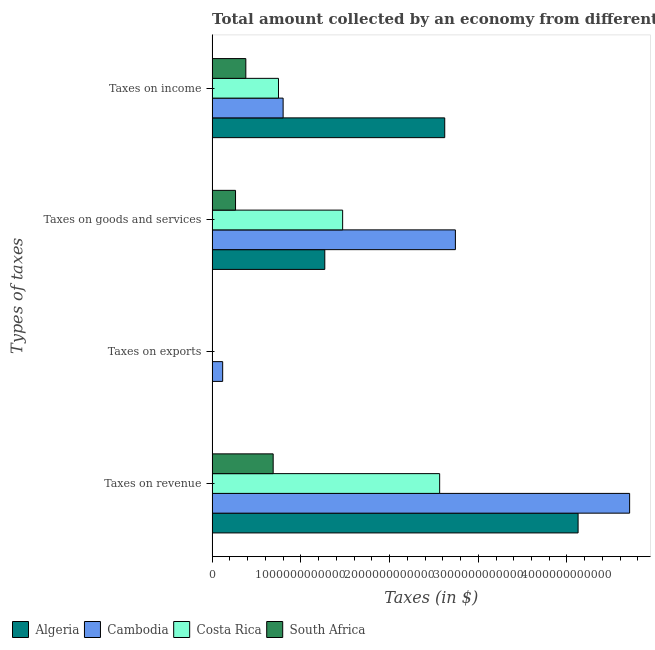How many bars are there on the 3rd tick from the bottom?
Your response must be concise. 4. What is the label of the 3rd group of bars from the top?
Make the answer very short. Taxes on exports. What is the amount collected as tax on income in South Africa?
Ensure brevity in your answer.  3.80e+11. Across all countries, what is the maximum amount collected as tax on income?
Offer a very short reply. 2.62e+12. Across all countries, what is the minimum amount collected as tax on income?
Make the answer very short. 3.80e+11. In which country was the amount collected as tax on exports maximum?
Provide a short and direct response. Cambodia. In which country was the amount collected as tax on income minimum?
Give a very brief answer. South Africa. What is the total amount collected as tax on revenue in the graph?
Give a very brief answer. 1.21e+13. What is the difference between the amount collected as tax on revenue in Cambodia and that in Costa Rica?
Keep it short and to the point. 2.14e+12. What is the difference between the amount collected as tax on income in Algeria and the amount collected as tax on exports in Cambodia?
Offer a very short reply. 2.50e+12. What is the average amount collected as tax on income per country?
Provide a succinct answer. 1.14e+12. What is the difference between the amount collected as tax on revenue and amount collected as tax on goods in Costa Rica?
Your answer should be compact. 1.09e+12. What is the ratio of the amount collected as tax on goods in Algeria to that in Cambodia?
Provide a succinct answer. 0.46. Is the amount collected as tax on goods in Costa Rica less than that in Cambodia?
Keep it short and to the point. Yes. Is the difference between the amount collected as tax on goods in South Africa and Algeria greater than the difference between the amount collected as tax on exports in South Africa and Algeria?
Ensure brevity in your answer.  No. What is the difference between the highest and the second highest amount collected as tax on exports?
Give a very brief answer. 1.15e+11. What is the difference between the highest and the lowest amount collected as tax on revenue?
Your response must be concise. 4.02e+12. In how many countries, is the amount collected as tax on exports greater than the average amount collected as tax on exports taken over all countries?
Offer a very short reply. 1. Is it the case that in every country, the sum of the amount collected as tax on revenue and amount collected as tax on exports is greater than the sum of amount collected as tax on goods and amount collected as tax on income?
Offer a very short reply. Yes. What does the 1st bar from the top in Taxes on exports represents?
Give a very brief answer. South Africa. What does the 1st bar from the bottom in Taxes on exports represents?
Your answer should be very brief. Algeria. Is it the case that in every country, the sum of the amount collected as tax on revenue and amount collected as tax on exports is greater than the amount collected as tax on goods?
Provide a short and direct response. Yes. Are all the bars in the graph horizontal?
Offer a terse response. Yes. How many countries are there in the graph?
Offer a terse response. 4. What is the difference between two consecutive major ticks on the X-axis?
Give a very brief answer. 1.00e+12. Are the values on the major ticks of X-axis written in scientific E-notation?
Make the answer very short. No. Does the graph contain any zero values?
Your answer should be compact. No. How are the legend labels stacked?
Ensure brevity in your answer.  Horizontal. What is the title of the graph?
Your answer should be compact. Total amount collected by an economy from different taxes in 2010. What is the label or title of the X-axis?
Give a very brief answer. Taxes (in $). What is the label or title of the Y-axis?
Offer a very short reply. Types of taxes. What is the Taxes (in $) in Algeria in Taxes on revenue?
Your response must be concise. 4.13e+12. What is the Taxes (in $) of Cambodia in Taxes on revenue?
Give a very brief answer. 4.71e+12. What is the Taxes (in $) of Costa Rica in Taxes on revenue?
Provide a succinct answer. 2.56e+12. What is the Taxes (in $) of South Africa in Taxes on revenue?
Keep it short and to the point. 6.88e+11. What is the Taxes (in $) of Algeria in Taxes on exports?
Keep it short and to the point. 3.00e+07. What is the Taxes (in $) of Cambodia in Taxes on exports?
Your answer should be very brief. 1.19e+11. What is the Taxes (in $) in Costa Rica in Taxes on exports?
Your answer should be compact. 3.97e+09. What is the Taxes (in $) of South Africa in Taxes on exports?
Offer a terse response. 7.04e+07. What is the Taxes (in $) in Algeria in Taxes on goods and services?
Ensure brevity in your answer.  1.27e+12. What is the Taxes (in $) of Cambodia in Taxes on goods and services?
Provide a short and direct response. 2.74e+12. What is the Taxes (in $) in Costa Rica in Taxes on goods and services?
Your response must be concise. 1.47e+12. What is the Taxes (in $) of South Africa in Taxes on goods and services?
Keep it short and to the point. 2.64e+11. What is the Taxes (in $) in Algeria in Taxes on income?
Your answer should be compact. 2.62e+12. What is the Taxes (in $) of Cambodia in Taxes on income?
Offer a very short reply. 8.00e+11. What is the Taxes (in $) in Costa Rica in Taxes on income?
Your answer should be compact. 7.48e+11. What is the Taxes (in $) of South Africa in Taxes on income?
Provide a short and direct response. 3.80e+11. Across all Types of taxes, what is the maximum Taxes (in $) in Algeria?
Make the answer very short. 4.13e+12. Across all Types of taxes, what is the maximum Taxes (in $) of Cambodia?
Make the answer very short. 4.71e+12. Across all Types of taxes, what is the maximum Taxes (in $) of Costa Rica?
Provide a short and direct response. 2.56e+12. Across all Types of taxes, what is the maximum Taxes (in $) in South Africa?
Offer a terse response. 6.88e+11. Across all Types of taxes, what is the minimum Taxes (in $) of Algeria?
Give a very brief answer. 3.00e+07. Across all Types of taxes, what is the minimum Taxes (in $) in Cambodia?
Make the answer very short. 1.19e+11. Across all Types of taxes, what is the minimum Taxes (in $) of Costa Rica?
Your answer should be compact. 3.97e+09. Across all Types of taxes, what is the minimum Taxes (in $) in South Africa?
Provide a short and direct response. 7.04e+07. What is the total Taxes (in $) of Algeria in the graph?
Keep it short and to the point. 8.02e+12. What is the total Taxes (in $) in Cambodia in the graph?
Ensure brevity in your answer.  8.37e+12. What is the total Taxes (in $) of Costa Rica in the graph?
Keep it short and to the point. 4.79e+12. What is the total Taxes (in $) of South Africa in the graph?
Offer a very short reply. 1.33e+12. What is the difference between the Taxes (in $) of Algeria in Taxes on revenue and that in Taxes on exports?
Your response must be concise. 4.13e+12. What is the difference between the Taxes (in $) of Cambodia in Taxes on revenue and that in Taxes on exports?
Give a very brief answer. 4.59e+12. What is the difference between the Taxes (in $) of Costa Rica in Taxes on revenue and that in Taxes on exports?
Provide a short and direct response. 2.56e+12. What is the difference between the Taxes (in $) in South Africa in Taxes on revenue and that in Taxes on exports?
Give a very brief answer. 6.88e+11. What is the difference between the Taxes (in $) of Algeria in Taxes on revenue and that in Taxes on goods and services?
Give a very brief answer. 2.86e+12. What is the difference between the Taxes (in $) of Cambodia in Taxes on revenue and that in Taxes on goods and services?
Make the answer very short. 1.96e+12. What is the difference between the Taxes (in $) in Costa Rica in Taxes on revenue and that in Taxes on goods and services?
Offer a terse response. 1.09e+12. What is the difference between the Taxes (in $) in South Africa in Taxes on revenue and that in Taxes on goods and services?
Your answer should be very brief. 4.24e+11. What is the difference between the Taxes (in $) of Algeria in Taxes on revenue and that in Taxes on income?
Keep it short and to the point. 1.50e+12. What is the difference between the Taxes (in $) of Cambodia in Taxes on revenue and that in Taxes on income?
Offer a very short reply. 3.91e+12. What is the difference between the Taxes (in $) in Costa Rica in Taxes on revenue and that in Taxes on income?
Keep it short and to the point. 1.82e+12. What is the difference between the Taxes (in $) of South Africa in Taxes on revenue and that in Taxes on income?
Provide a short and direct response. 3.08e+11. What is the difference between the Taxes (in $) in Algeria in Taxes on exports and that in Taxes on goods and services?
Offer a very short reply. -1.27e+12. What is the difference between the Taxes (in $) of Cambodia in Taxes on exports and that in Taxes on goods and services?
Your answer should be very brief. -2.62e+12. What is the difference between the Taxes (in $) in Costa Rica in Taxes on exports and that in Taxes on goods and services?
Ensure brevity in your answer.  -1.47e+12. What is the difference between the Taxes (in $) of South Africa in Taxes on exports and that in Taxes on goods and services?
Give a very brief answer. -2.64e+11. What is the difference between the Taxes (in $) in Algeria in Taxes on exports and that in Taxes on income?
Provide a succinct answer. -2.62e+12. What is the difference between the Taxes (in $) of Cambodia in Taxes on exports and that in Taxes on income?
Your answer should be very brief. -6.81e+11. What is the difference between the Taxes (in $) of Costa Rica in Taxes on exports and that in Taxes on income?
Your answer should be compact. -7.44e+11. What is the difference between the Taxes (in $) of South Africa in Taxes on exports and that in Taxes on income?
Make the answer very short. -3.80e+11. What is the difference between the Taxes (in $) of Algeria in Taxes on goods and services and that in Taxes on income?
Your answer should be very brief. -1.35e+12. What is the difference between the Taxes (in $) of Cambodia in Taxes on goods and services and that in Taxes on income?
Offer a terse response. 1.94e+12. What is the difference between the Taxes (in $) in Costa Rica in Taxes on goods and services and that in Taxes on income?
Offer a very short reply. 7.23e+11. What is the difference between the Taxes (in $) in South Africa in Taxes on goods and services and that in Taxes on income?
Your response must be concise. -1.16e+11. What is the difference between the Taxes (in $) of Algeria in Taxes on revenue and the Taxes (in $) of Cambodia in Taxes on exports?
Your response must be concise. 4.01e+12. What is the difference between the Taxes (in $) in Algeria in Taxes on revenue and the Taxes (in $) in Costa Rica in Taxes on exports?
Offer a terse response. 4.12e+12. What is the difference between the Taxes (in $) in Algeria in Taxes on revenue and the Taxes (in $) in South Africa in Taxes on exports?
Offer a very short reply. 4.13e+12. What is the difference between the Taxes (in $) in Cambodia in Taxes on revenue and the Taxes (in $) in Costa Rica in Taxes on exports?
Keep it short and to the point. 4.70e+12. What is the difference between the Taxes (in $) in Cambodia in Taxes on revenue and the Taxes (in $) in South Africa in Taxes on exports?
Keep it short and to the point. 4.71e+12. What is the difference between the Taxes (in $) of Costa Rica in Taxes on revenue and the Taxes (in $) of South Africa in Taxes on exports?
Offer a terse response. 2.56e+12. What is the difference between the Taxes (in $) of Algeria in Taxes on revenue and the Taxes (in $) of Cambodia in Taxes on goods and services?
Offer a terse response. 1.38e+12. What is the difference between the Taxes (in $) of Algeria in Taxes on revenue and the Taxes (in $) of Costa Rica in Taxes on goods and services?
Your answer should be very brief. 2.65e+12. What is the difference between the Taxes (in $) of Algeria in Taxes on revenue and the Taxes (in $) of South Africa in Taxes on goods and services?
Provide a short and direct response. 3.86e+12. What is the difference between the Taxes (in $) of Cambodia in Taxes on revenue and the Taxes (in $) of Costa Rica in Taxes on goods and services?
Ensure brevity in your answer.  3.23e+12. What is the difference between the Taxes (in $) of Cambodia in Taxes on revenue and the Taxes (in $) of South Africa in Taxes on goods and services?
Keep it short and to the point. 4.44e+12. What is the difference between the Taxes (in $) of Costa Rica in Taxes on revenue and the Taxes (in $) of South Africa in Taxes on goods and services?
Your response must be concise. 2.30e+12. What is the difference between the Taxes (in $) in Algeria in Taxes on revenue and the Taxes (in $) in Cambodia in Taxes on income?
Provide a short and direct response. 3.33e+12. What is the difference between the Taxes (in $) in Algeria in Taxes on revenue and the Taxes (in $) in Costa Rica in Taxes on income?
Give a very brief answer. 3.38e+12. What is the difference between the Taxes (in $) of Algeria in Taxes on revenue and the Taxes (in $) of South Africa in Taxes on income?
Your answer should be very brief. 3.75e+12. What is the difference between the Taxes (in $) in Cambodia in Taxes on revenue and the Taxes (in $) in Costa Rica in Taxes on income?
Keep it short and to the point. 3.96e+12. What is the difference between the Taxes (in $) of Cambodia in Taxes on revenue and the Taxes (in $) of South Africa in Taxes on income?
Your answer should be very brief. 4.33e+12. What is the difference between the Taxes (in $) of Costa Rica in Taxes on revenue and the Taxes (in $) of South Africa in Taxes on income?
Provide a succinct answer. 2.18e+12. What is the difference between the Taxes (in $) in Algeria in Taxes on exports and the Taxes (in $) in Cambodia in Taxes on goods and services?
Provide a succinct answer. -2.74e+12. What is the difference between the Taxes (in $) of Algeria in Taxes on exports and the Taxes (in $) of Costa Rica in Taxes on goods and services?
Your answer should be compact. -1.47e+12. What is the difference between the Taxes (in $) of Algeria in Taxes on exports and the Taxes (in $) of South Africa in Taxes on goods and services?
Give a very brief answer. -2.64e+11. What is the difference between the Taxes (in $) in Cambodia in Taxes on exports and the Taxes (in $) in Costa Rica in Taxes on goods and services?
Ensure brevity in your answer.  -1.35e+12. What is the difference between the Taxes (in $) of Cambodia in Taxes on exports and the Taxes (in $) of South Africa in Taxes on goods and services?
Give a very brief answer. -1.45e+11. What is the difference between the Taxes (in $) in Costa Rica in Taxes on exports and the Taxes (in $) in South Africa in Taxes on goods and services?
Give a very brief answer. -2.60e+11. What is the difference between the Taxes (in $) in Algeria in Taxes on exports and the Taxes (in $) in Cambodia in Taxes on income?
Offer a very short reply. -8.00e+11. What is the difference between the Taxes (in $) in Algeria in Taxes on exports and the Taxes (in $) in Costa Rica in Taxes on income?
Offer a very short reply. -7.48e+11. What is the difference between the Taxes (in $) of Algeria in Taxes on exports and the Taxes (in $) of South Africa in Taxes on income?
Ensure brevity in your answer.  -3.80e+11. What is the difference between the Taxes (in $) of Cambodia in Taxes on exports and the Taxes (in $) of Costa Rica in Taxes on income?
Your response must be concise. -6.29e+11. What is the difference between the Taxes (in $) in Cambodia in Taxes on exports and the Taxes (in $) in South Africa in Taxes on income?
Your response must be concise. -2.61e+11. What is the difference between the Taxes (in $) in Costa Rica in Taxes on exports and the Taxes (in $) in South Africa in Taxes on income?
Your answer should be compact. -3.76e+11. What is the difference between the Taxes (in $) in Algeria in Taxes on goods and services and the Taxes (in $) in Cambodia in Taxes on income?
Offer a very short reply. 4.70e+11. What is the difference between the Taxes (in $) of Algeria in Taxes on goods and services and the Taxes (in $) of Costa Rica in Taxes on income?
Offer a very short reply. 5.22e+11. What is the difference between the Taxes (in $) of Algeria in Taxes on goods and services and the Taxes (in $) of South Africa in Taxes on income?
Make the answer very short. 8.90e+11. What is the difference between the Taxes (in $) of Cambodia in Taxes on goods and services and the Taxes (in $) of Costa Rica in Taxes on income?
Keep it short and to the point. 1.99e+12. What is the difference between the Taxes (in $) in Cambodia in Taxes on goods and services and the Taxes (in $) in South Africa in Taxes on income?
Your answer should be very brief. 2.36e+12. What is the difference between the Taxes (in $) of Costa Rica in Taxes on goods and services and the Taxes (in $) of South Africa in Taxes on income?
Give a very brief answer. 1.09e+12. What is the average Taxes (in $) in Algeria per Types of taxes?
Give a very brief answer. 2.00e+12. What is the average Taxes (in $) in Cambodia per Types of taxes?
Keep it short and to the point. 2.09e+12. What is the average Taxes (in $) in Costa Rica per Types of taxes?
Provide a short and direct response. 1.20e+12. What is the average Taxes (in $) of South Africa per Types of taxes?
Your answer should be compact. 3.33e+11. What is the difference between the Taxes (in $) in Algeria and Taxes (in $) in Cambodia in Taxes on revenue?
Your answer should be very brief. -5.81e+11. What is the difference between the Taxes (in $) in Algeria and Taxes (in $) in Costa Rica in Taxes on revenue?
Make the answer very short. 1.56e+12. What is the difference between the Taxes (in $) in Algeria and Taxes (in $) in South Africa in Taxes on revenue?
Your answer should be very brief. 3.44e+12. What is the difference between the Taxes (in $) of Cambodia and Taxes (in $) of Costa Rica in Taxes on revenue?
Provide a succinct answer. 2.14e+12. What is the difference between the Taxes (in $) of Cambodia and Taxes (in $) of South Africa in Taxes on revenue?
Make the answer very short. 4.02e+12. What is the difference between the Taxes (in $) in Costa Rica and Taxes (in $) in South Africa in Taxes on revenue?
Keep it short and to the point. 1.88e+12. What is the difference between the Taxes (in $) of Algeria and Taxes (in $) of Cambodia in Taxes on exports?
Your answer should be very brief. -1.19e+11. What is the difference between the Taxes (in $) of Algeria and Taxes (in $) of Costa Rica in Taxes on exports?
Keep it short and to the point. -3.94e+09. What is the difference between the Taxes (in $) in Algeria and Taxes (in $) in South Africa in Taxes on exports?
Provide a short and direct response. -4.04e+07. What is the difference between the Taxes (in $) of Cambodia and Taxes (in $) of Costa Rica in Taxes on exports?
Ensure brevity in your answer.  1.15e+11. What is the difference between the Taxes (in $) in Cambodia and Taxes (in $) in South Africa in Taxes on exports?
Offer a terse response. 1.19e+11. What is the difference between the Taxes (in $) of Costa Rica and Taxes (in $) of South Africa in Taxes on exports?
Make the answer very short. 3.90e+09. What is the difference between the Taxes (in $) in Algeria and Taxes (in $) in Cambodia in Taxes on goods and services?
Make the answer very short. -1.47e+12. What is the difference between the Taxes (in $) in Algeria and Taxes (in $) in Costa Rica in Taxes on goods and services?
Provide a succinct answer. -2.01e+11. What is the difference between the Taxes (in $) in Algeria and Taxes (in $) in South Africa in Taxes on goods and services?
Offer a terse response. 1.01e+12. What is the difference between the Taxes (in $) of Cambodia and Taxes (in $) of Costa Rica in Taxes on goods and services?
Your answer should be very brief. 1.27e+12. What is the difference between the Taxes (in $) in Cambodia and Taxes (in $) in South Africa in Taxes on goods and services?
Ensure brevity in your answer.  2.48e+12. What is the difference between the Taxes (in $) of Costa Rica and Taxes (in $) of South Africa in Taxes on goods and services?
Make the answer very short. 1.21e+12. What is the difference between the Taxes (in $) in Algeria and Taxes (in $) in Cambodia in Taxes on income?
Offer a very short reply. 1.82e+12. What is the difference between the Taxes (in $) of Algeria and Taxes (in $) of Costa Rica in Taxes on income?
Your response must be concise. 1.87e+12. What is the difference between the Taxes (in $) of Algeria and Taxes (in $) of South Africa in Taxes on income?
Keep it short and to the point. 2.24e+12. What is the difference between the Taxes (in $) of Cambodia and Taxes (in $) of Costa Rica in Taxes on income?
Provide a succinct answer. 5.23e+1. What is the difference between the Taxes (in $) of Cambodia and Taxes (in $) of South Africa in Taxes on income?
Offer a terse response. 4.20e+11. What is the difference between the Taxes (in $) in Costa Rica and Taxes (in $) in South Africa in Taxes on income?
Provide a short and direct response. 3.68e+11. What is the ratio of the Taxes (in $) of Algeria in Taxes on revenue to that in Taxes on exports?
Provide a short and direct response. 1.38e+05. What is the ratio of the Taxes (in $) of Cambodia in Taxes on revenue to that in Taxes on exports?
Provide a succinct answer. 39.58. What is the ratio of the Taxes (in $) in Costa Rica in Taxes on revenue to that in Taxes on exports?
Make the answer very short. 645.6. What is the ratio of the Taxes (in $) in South Africa in Taxes on revenue to that in Taxes on exports?
Offer a terse response. 9776.18. What is the ratio of the Taxes (in $) in Algeria in Taxes on revenue to that in Taxes on goods and services?
Your response must be concise. 3.25. What is the ratio of the Taxes (in $) in Cambodia in Taxes on revenue to that in Taxes on goods and services?
Make the answer very short. 1.72. What is the ratio of the Taxes (in $) in Costa Rica in Taxes on revenue to that in Taxes on goods and services?
Keep it short and to the point. 1.74. What is the ratio of the Taxes (in $) of South Africa in Taxes on revenue to that in Taxes on goods and services?
Offer a very short reply. 2.61. What is the ratio of the Taxes (in $) in Algeria in Taxes on revenue to that in Taxes on income?
Provide a succinct answer. 1.57. What is the ratio of the Taxes (in $) in Cambodia in Taxes on revenue to that in Taxes on income?
Ensure brevity in your answer.  5.88. What is the ratio of the Taxes (in $) of Costa Rica in Taxes on revenue to that in Taxes on income?
Keep it short and to the point. 3.43. What is the ratio of the Taxes (in $) in South Africa in Taxes on revenue to that in Taxes on income?
Your answer should be compact. 1.81. What is the ratio of the Taxes (in $) in Algeria in Taxes on exports to that in Taxes on goods and services?
Offer a very short reply. 0. What is the ratio of the Taxes (in $) in Cambodia in Taxes on exports to that in Taxes on goods and services?
Your answer should be very brief. 0.04. What is the ratio of the Taxes (in $) in Costa Rica in Taxes on exports to that in Taxes on goods and services?
Ensure brevity in your answer.  0. What is the ratio of the Taxes (in $) of South Africa in Taxes on exports to that in Taxes on goods and services?
Provide a short and direct response. 0. What is the ratio of the Taxes (in $) of Algeria in Taxes on exports to that in Taxes on income?
Ensure brevity in your answer.  0. What is the ratio of the Taxes (in $) in Cambodia in Taxes on exports to that in Taxes on income?
Your response must be concise. 0.15. What is the ratio of the Taxes (in $) of Costa Rica in Taxes on exports to that in Taxes on income?
Offer a very short reply. 0.01. What is the ratio of the Taxes (in $) of South Africa in Taxes on exports to that in Taxes on income?
Provide a short and direct response. 0. What is the ratio of the Taxes (in $) in Algeria in Taxes on goods and services to that in Taxes on income?
Make the answer very short. 0.48. What is the ratio of the Taxes (in $) of Cambodia in Taxes on goods and services to that in Taxes on income?
Provide a short and direct response. 3.43. What is the ratio of the Taxes (in $) in Costa Rica in Taxes on goods and services to that in Taxes on income?
Keep it short and to the point. 1.97. What is the ratio of the Taxes (in $) of South Africa in Taxes on goods and services to that in Taxes on income?
Keep it short and to the point. 0.69. What is the difference between the highest and the second highest Taxes (in $) of Algeria?
Your answer should be very brief. 1.50e+12. What is the difference between the highest and the second highest Taxes (in $) in Cambodia?
Your answer should be very brief. 1.96e+12. What is the difference between the highest and the second highest Taxes (in $) in Costa Rica?
Provide a short and direct response. 1.09e+12. What is the difference between the highest and the second highest Taxes (in $) in South Africa?
Keep it short and to the point. 3.08e+11. What is the difference between the highest and the lowest Taxes (in $) in Algeria?
Provide a succinct answer. 4.13e+12. What is the difference between the highest and the lowest Taxes (in $) of Cambodia?
Your response must be concise. 4.59e+12. What is the difference between the highest and the lowest Taxes (in $) of Costa Rica?
Make the answer very short. 2.56e+12. What is the difference between the highest and the lowest Taxes (in $) of South Africa?
Give a very brief answer. 6.88e+11. 